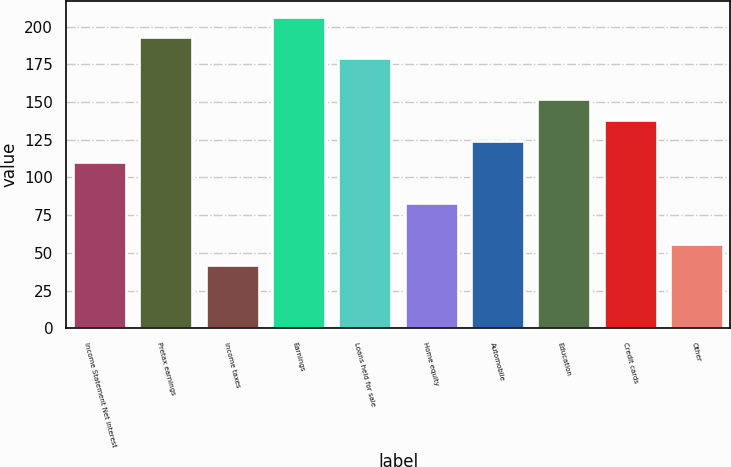Convert chart to OTSL. <chart><loc_0><loc_0><loc_500><loc_500><bar_chart><fcel>Income Statement Net interest<fcel>Pretax earnings<fcel>Income taxes<fcel>Earnings<fcel>Loans held for sale<fcel>Home equity<fcel>Automobile<fcel>Education<fcel>Credit cards<fcel>Other<nl><fcel>110.6<fcel>192.8<fcel>42.1<fcel>206.5<fcel>179.1<fcel>83.2<fcel>124.3<fcel>151.7<fcel>138<fcel>55.8<nl></chart> 